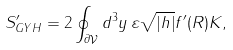Convert formula to latex. <formula><loc_0><loc_0><loc_500><loc_500>S ^ { \prime } _ { G Y H } = 2 \oint _ { \partial \mathcal { V } } d ^ { 3 } y \, \varepsilon \sqrt { | h | } f ^ { \prime } ( R ) K ,</formula> 